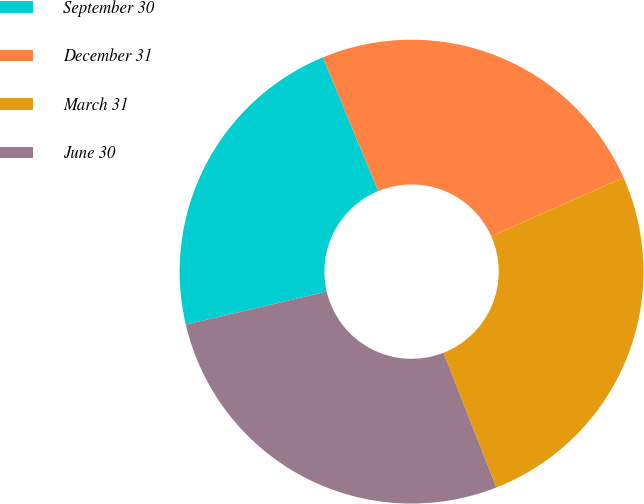<chart> <loc_0><loc_0><loc_500><loc_500><pie_chart><fcel>September 30<fcel>December 31<fcel>March 31<fcel>June 30<nl><fcel>22.43%<fcel>24.6%<fcel>25.69%<fcel>27.29%<nl></chart> 